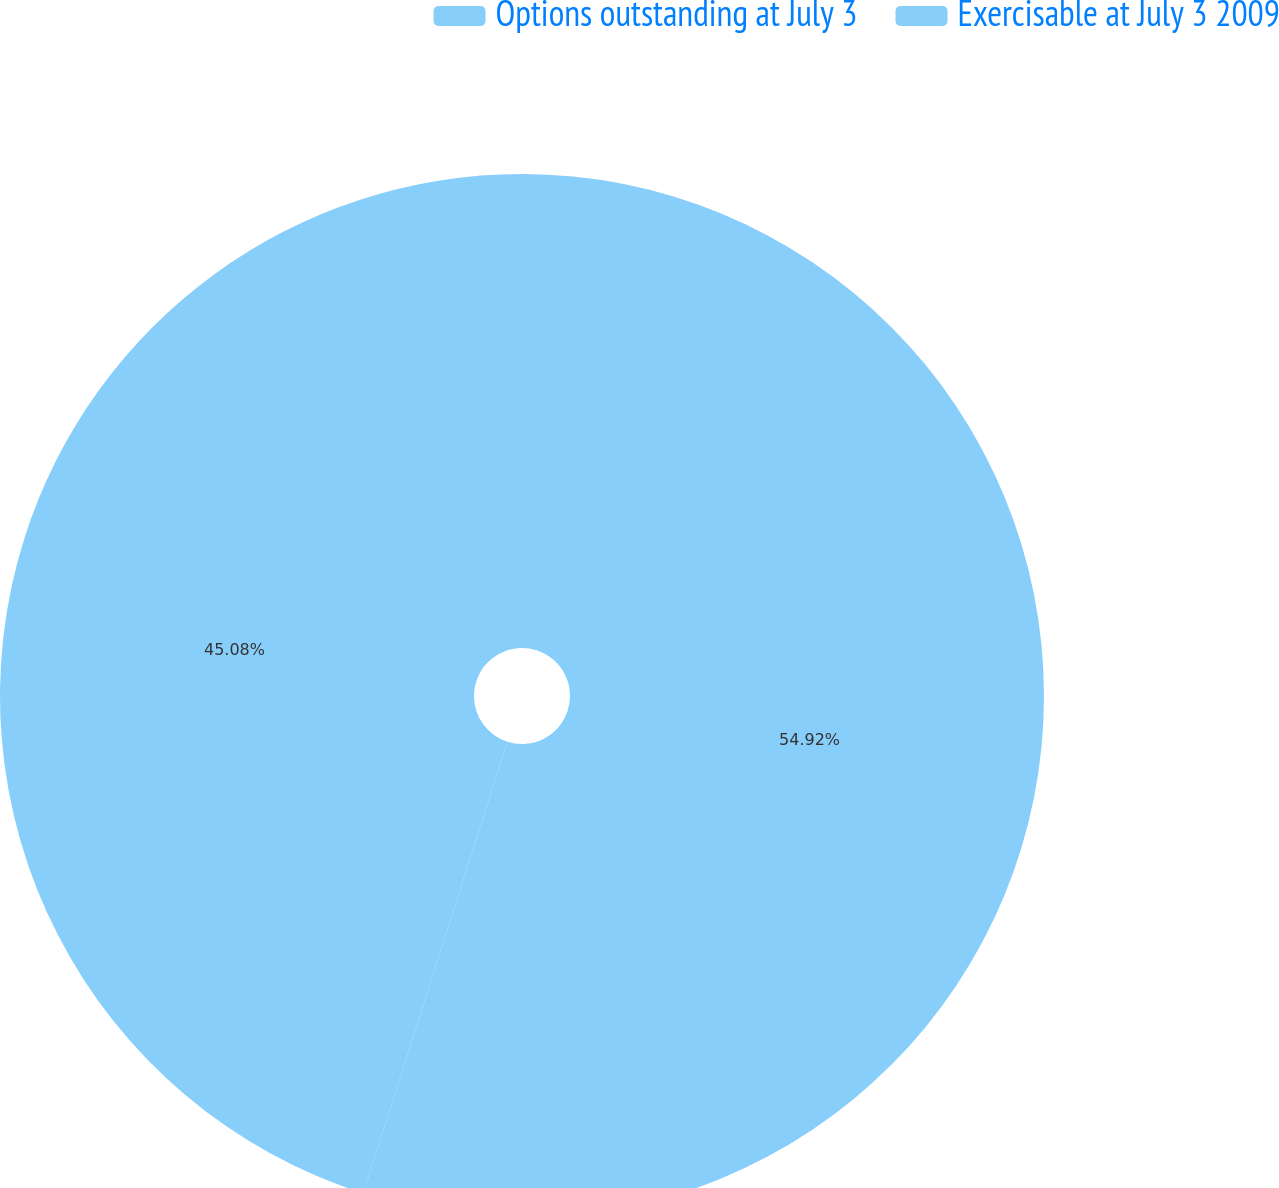Convert chart. <chart><loc_0><loc_0><loc_500><loc_500><pie_chart><fcel>Options outstanding at July 3<fcel>Exercisable at July 3 2009<nl><fcel>54.92%<fcel>45.08%<nl></chart> 